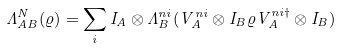<formula> <loc_0><loc_0><loc_500><loc_500>\Lambda ^ { N } _ { A B } ( \varrho ) = \sum _ { i } I _ { A } \otimes \Lambda _ { B } ^ { n i } ( V _ { A } ^ { n i } \otimes I _ { B } \varrho V _ { A } ^ { n i \dagger } \otimes I _ { B } )</formula> 